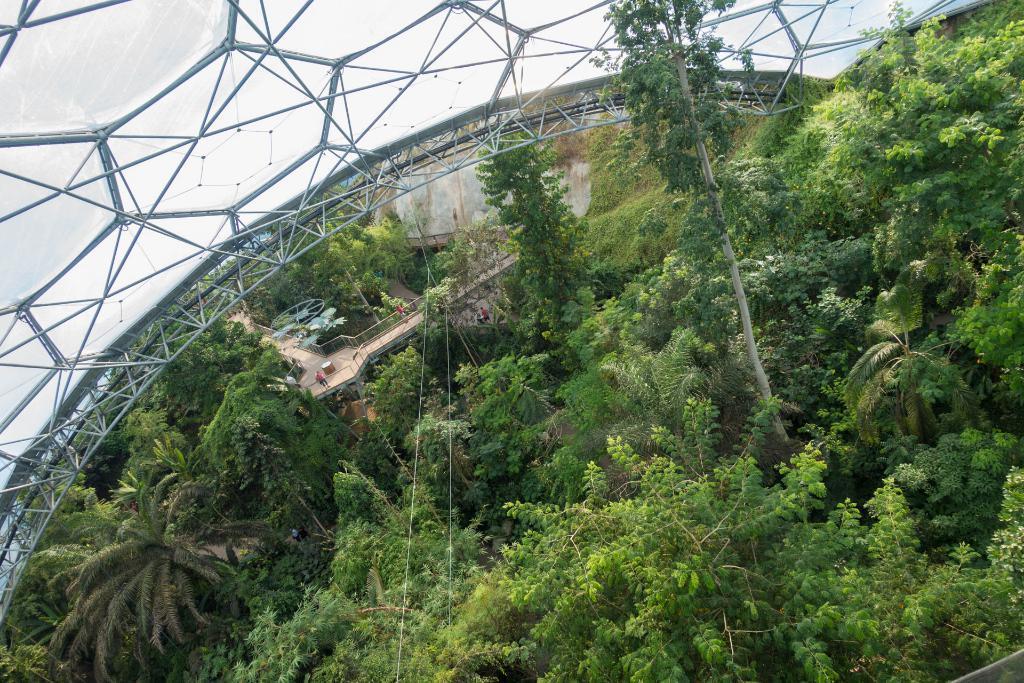Could you give a brief overview of what you see in this image? In this image there are some trees and bridge as we can see in the bottom of this image. There is a glass roof on the top of this image. 